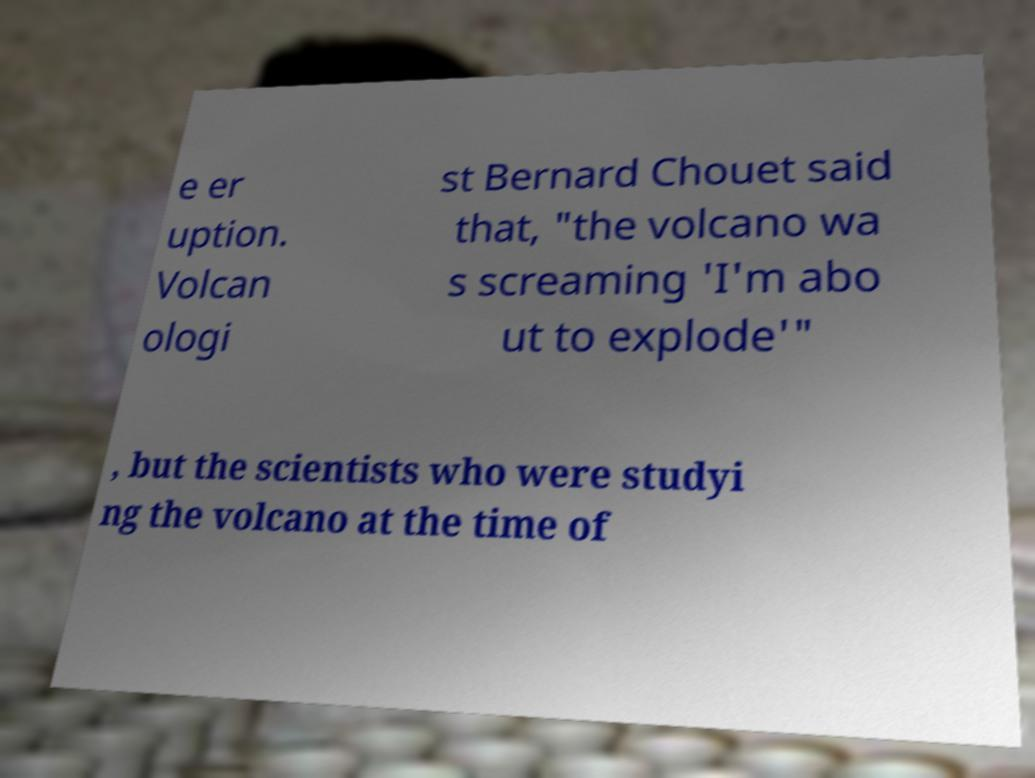For documentation purposes, I need the text within this image transcribed. Could you provide that? e er uption. Volcan ologi st Bernard Chouet said that, "the volcano wa s screaming 'I'm abo ut to explode'" , but the scientists who were studyi ng the volcano at the time of 